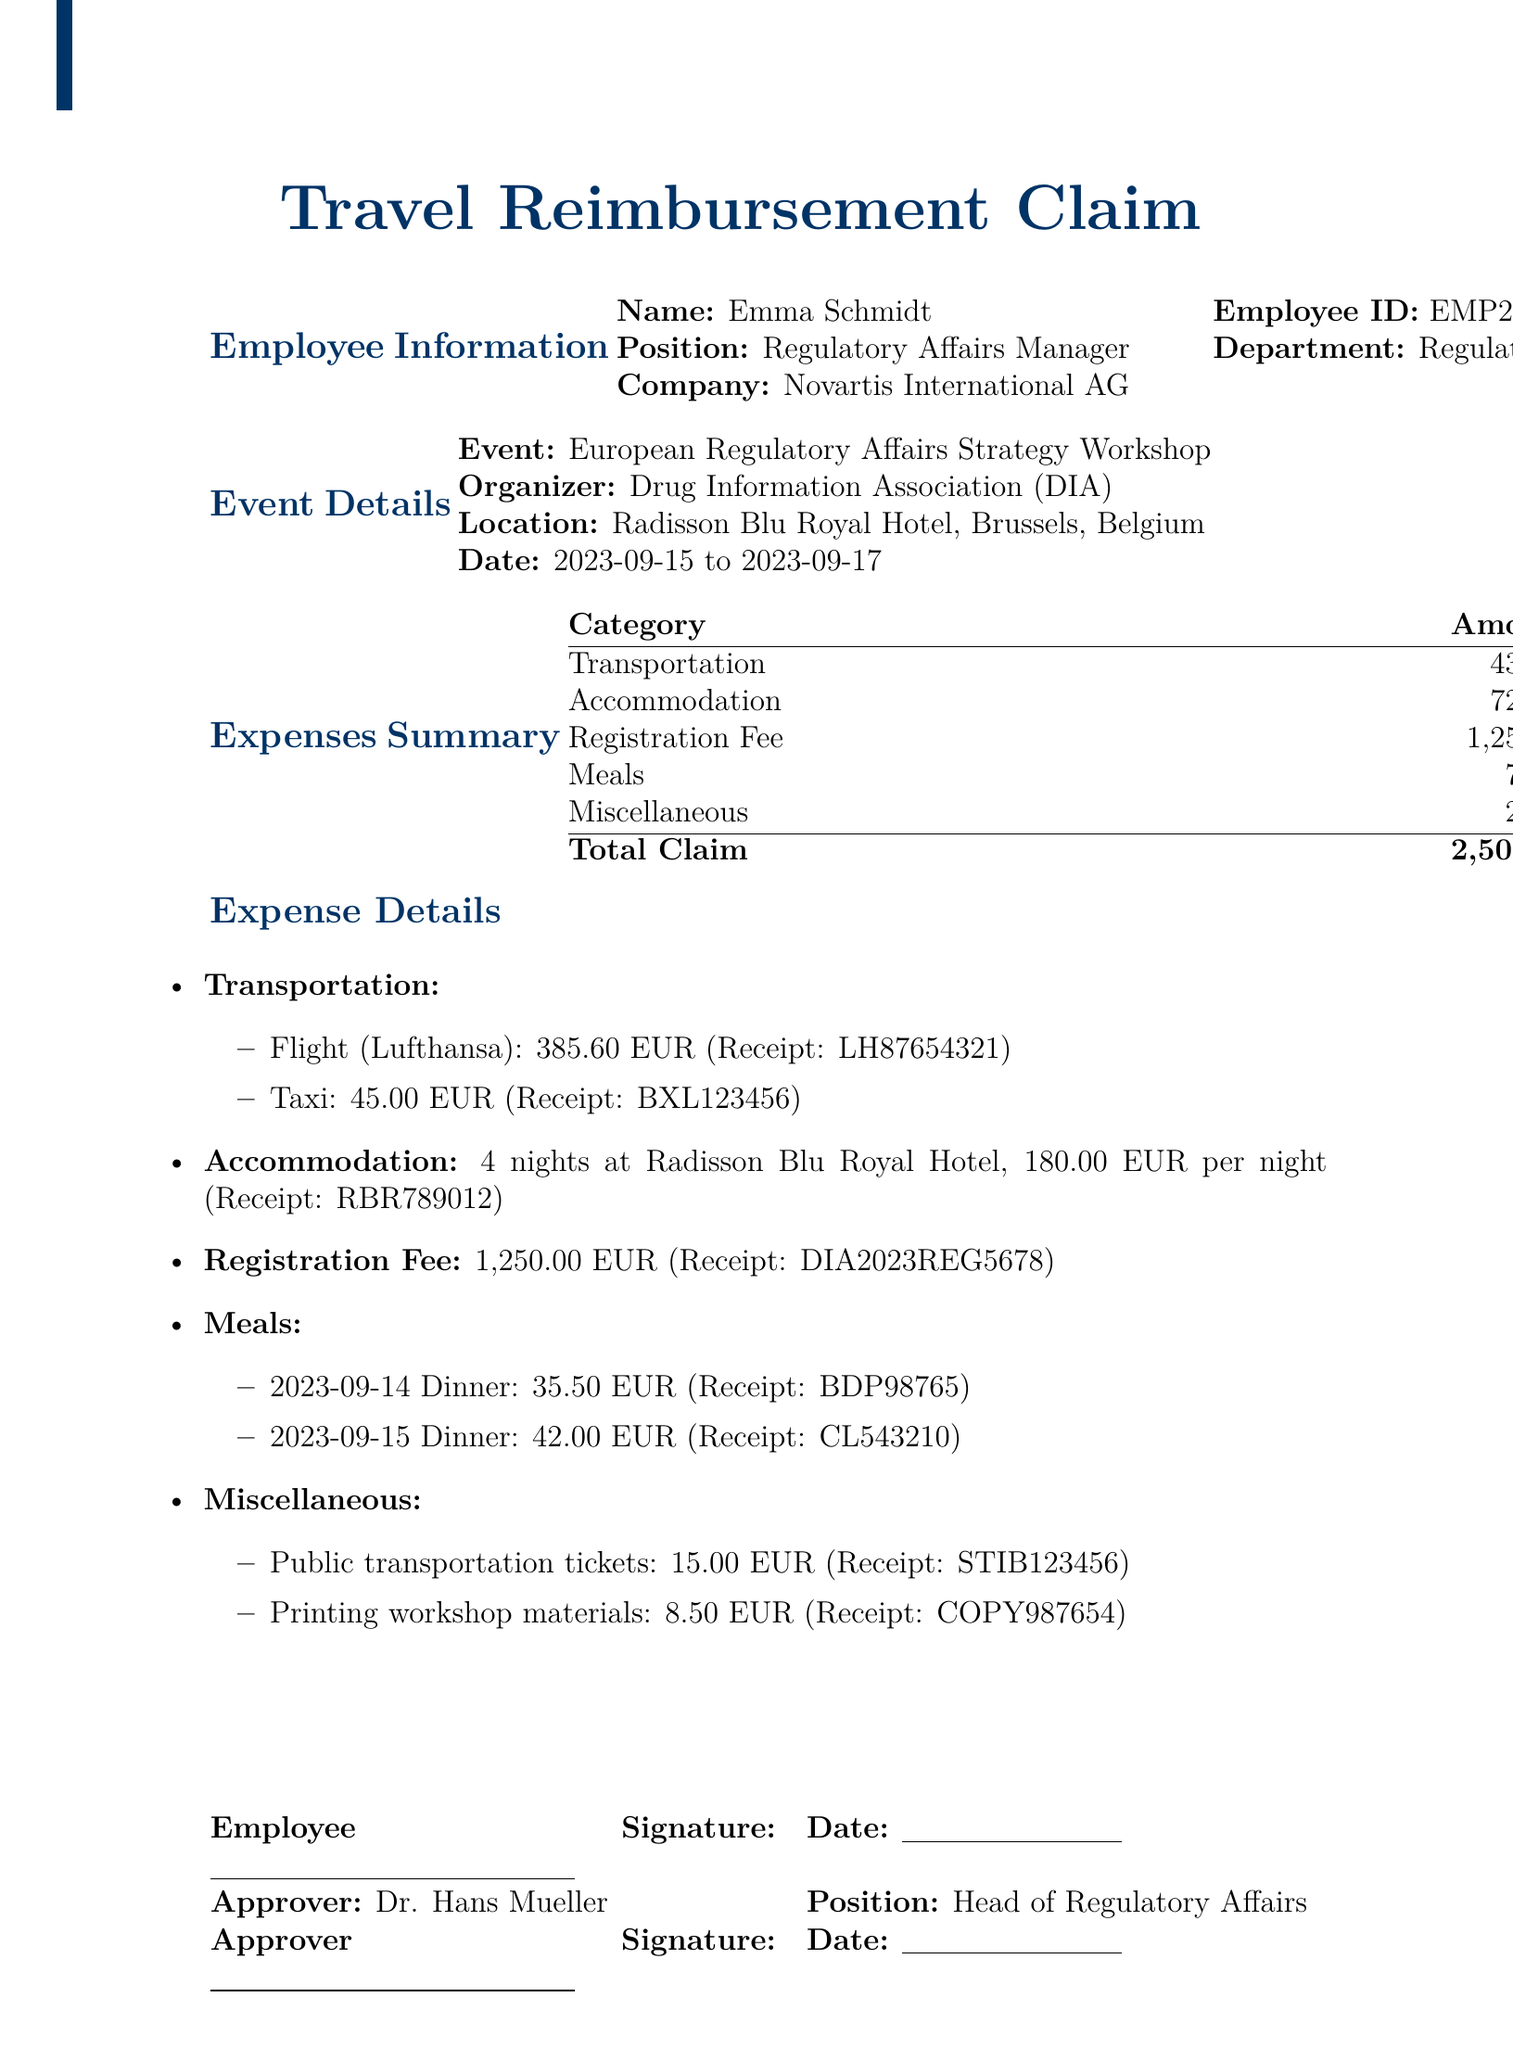what is the name of the employee? The employee's name is listed at the top of the document under employee information.
Answer: Emma Schmidt what is the position of the employee? The employee's position is specified in the employee information section of the document.
Answer: Regulatory Affairs Manager what are the dates of the workshop? The dates of the event are stated in the event details section.
Answer: 2023-09-15 to 2023-09-17 what is the total cost of transportation? The total cost is calculated from the individual transportation expenses listed in the document.
Answer: 430.60 EUR how much was spent on the registration fee? The amount for the registration fee is clearly stated in the expense summary.
Answer: 1,250.00 EUR how many nights did the employee stay at the hotel? The number of nights stayed is provided in the accommodation section of the document.
Answer: 4 what was the cost of the taxi from the airport? The cost is specified in the transportation section of the document.
Answer: 45.00 EUR who approved the travel reimbursement claim? The approver's name is mentioned towards the end of the document.
Answer: Dr. Hans Mueller what is the daily meal allowance according to company policy? The daily meal allowance is outlined in the company policy section of the document.
Answer: 60.00 EUR 